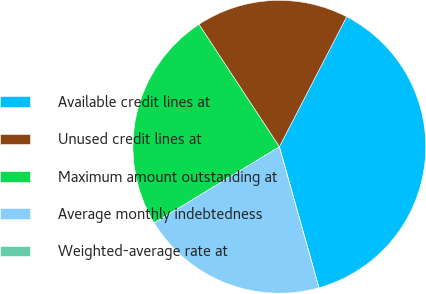Convert chart. <chart><loc_0><loc_0><loc_500><loc_500><pie_chart><fcel>Available credit lines at<fcel>Unused credit lines at<fcel>Maximum amount outstanding at<fcel>Average monthly indebtedness<fcel>Weighted-average rate at<nl><fcel>38.04%<fcel>16.85%<fcel>24.46%<fcel>20.65%<fcel>0.0%<nl></chart> 